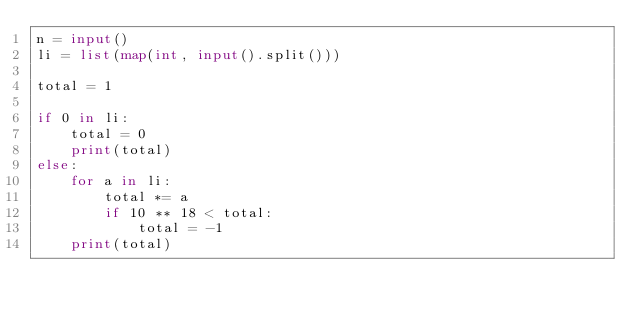Convert code to text. <code><loc_0><loc_0><loc_500><loc_500><_Python_>n = input()
li = list(map(int, input().split())) 

total = 1

if 0 in li:
    total = 0
    print(total)
else:
    for a in li:
        total *= a
        if 10 ** 18 < total:
            total = -1
    print(total)</code> 